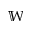<formula> <loc_0><loc_0><loc_500><loc_500>\mathbb { W }</formula> 